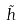Convert formula to latex. <formula><loc_0><loc_0><loc_500><loc_500>\tilde { h }</formula> 